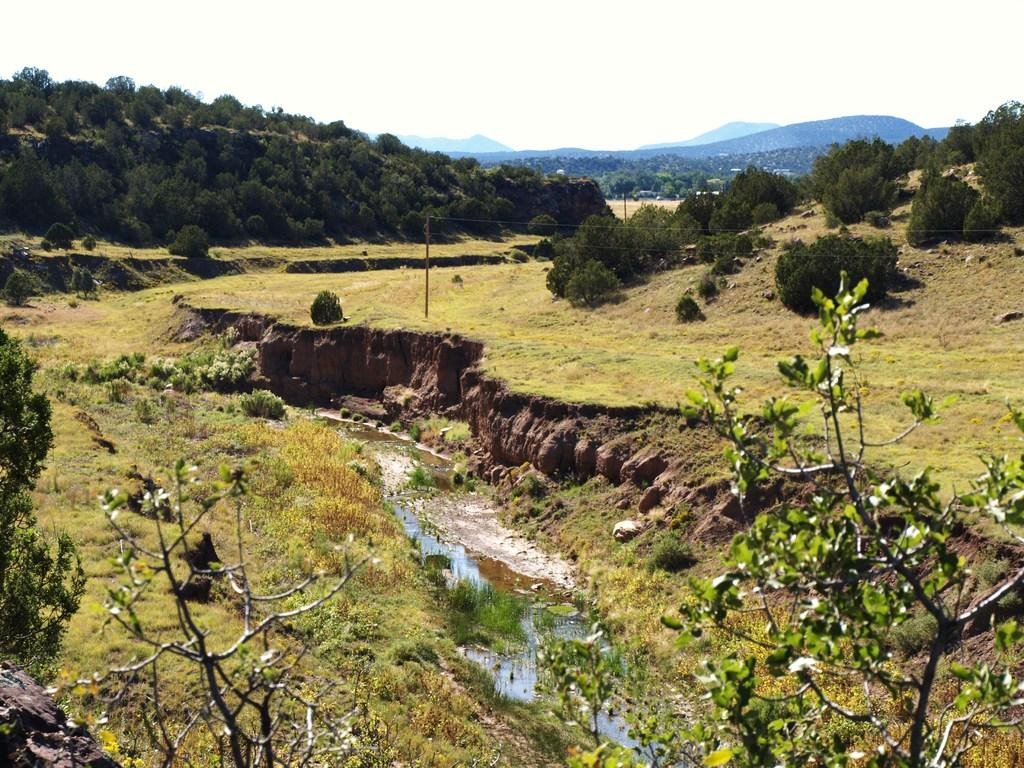What type of vegetation can be seen in the image? There are plants and grass in the image. What else can be seen in the image besides vegetation? There is a pole with wires, water, a group of trees, hills, and the sky visible in the image. How would you describe the sky in the image? The sky appears cloudy in the image. Can you tell me how many people are pulling the scene in the image? There are no people pulling the scene in the image, as it is a landscape with natural elements like plants, grass, water, trees, hills, and a cloudy sky. Is there a yard visible in the image? There is no yard mentioned or visible in the image; it features a landscape with natural elements. 